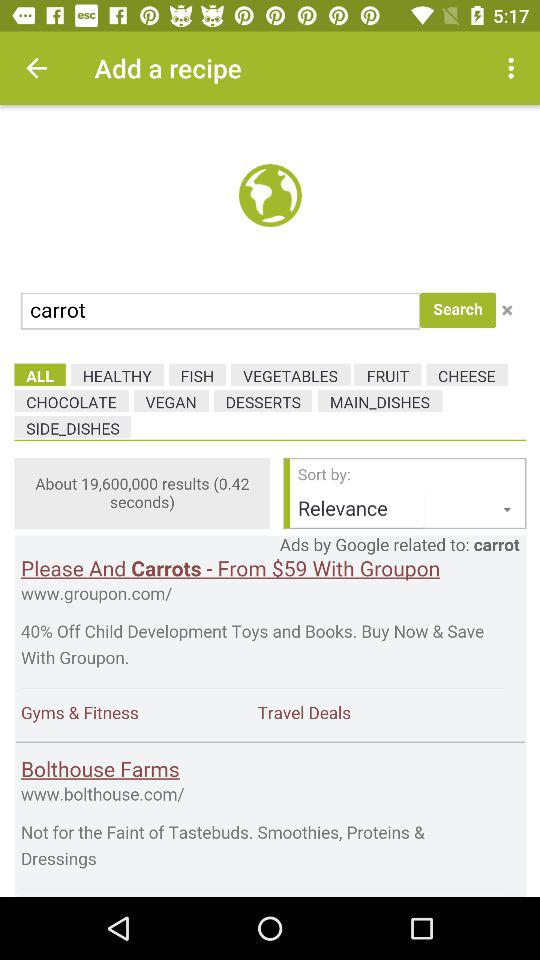What vegetable is being searched for? The vegetable that is being searched for is "carrot". 